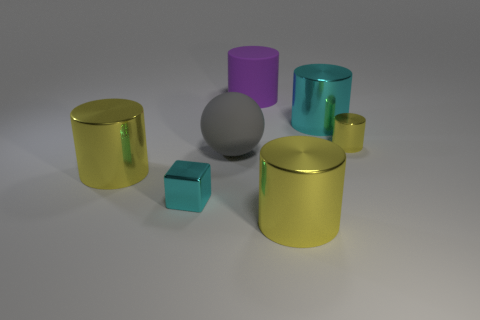Subtract all brown balls. How many yellow cylinders are left? 3 Subtract 3 cylinders. How many cylinders are left? 2 Subtract all cyan cylinders. How many cylinders are left? 4 Subtract all tiny metal cylinders. How many cylinders are left? 4 Subtract all cyan cylinders. Subtract all gray spheres. How many cylinders are left? 4 Add 1 big yellow shiny things. How many objects exist? 8 Subtract all cubes. How many objects are left? 6 Subtract all big purple metallic cylinders. Subtract all purple objects. How many objects are left? 6 Add 3 shiny blocks. How many shiny blocks are left? 4 Add 1 metal things. How many metal things exist? 6 